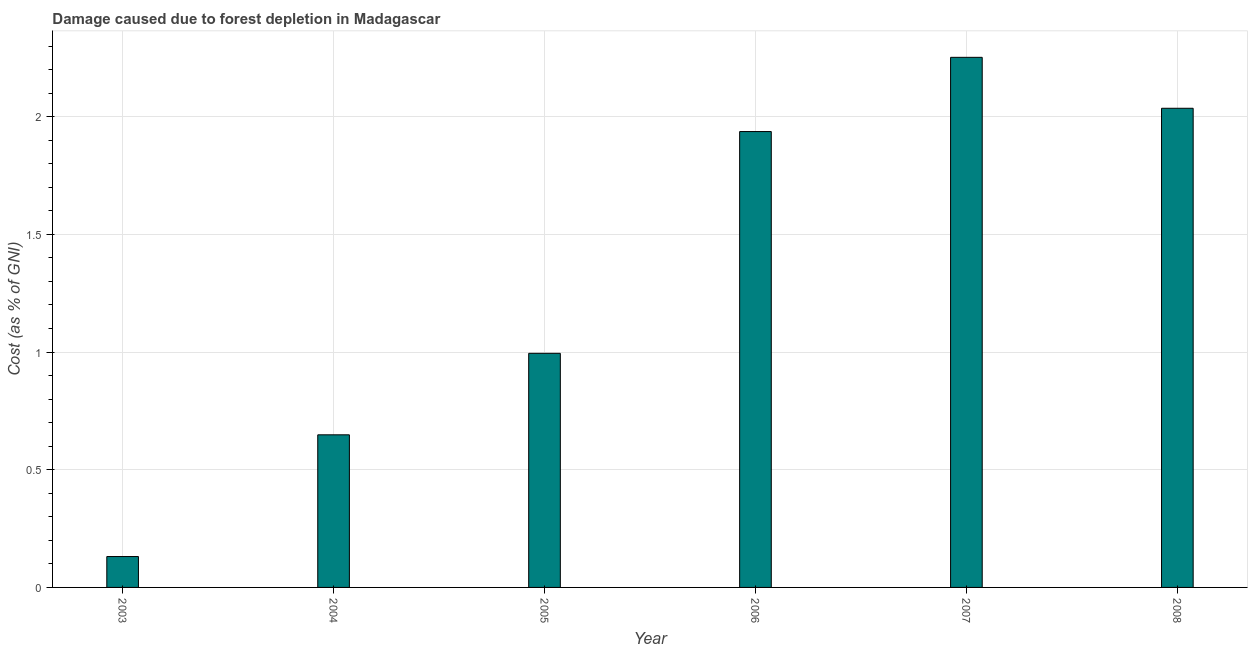Does the graph contain any zero values?
Ensure brevity in your answer.  No. Does the graph contain grids?
Your response must be concise. Yes. What is the title of the graph?
Give a very brief answer. Damage caused due to forest depletion in Madagascar. What is the label or title of the X-axis?
Provide a short and direct response. Year. What is the label or title of the Y-axis?
Offer a terse response. Cost (as % of GNI). What is the damage caused due to forest depletion in 2006?
Offer a terse response. 1.94. Across all years, what is the maximum damage caused due to forest depletion?
Your answer should be compact. 2.25. Across all years, what is the minimum damage caused due to forest depletion?
Your answer should be compact. 0.13. What is the sum of the damage caused due to forest depletion?
Provide a short and direct response. 8. What is the difference between the damage caused due to forest depletion in 2005 and 2007?
Provide a short and direct response. -1.26. What is the average damage caused due to forest depletion per year?
Make the answer very short. 1.33. What is the median damage caused due to forest depletion?
Provide a succinct answer. 1.47. In how many years, is the damage caused due to forest depletion greater than 1.3 %?
Provide a short and direct response. 3. What is the ratio of the damage caused due to forest depletion in 2004 to that in 2007?
Your response must be concise. 0.29. Is the damage caused due to forest depletion in 2003 less than that in 2008?
Your answer should be very brief. Yes. Is the difference between the damage caused due to forest depletion in 2004 and 2005 greater than the difference between any two years?
Your answer should be compact. No. What is the difference between the highest and the second highest damage caused due to forest depletion?
Provide a succinct answer. 0.22. What is the difference between the highest and the lowest damage caused due to forest depletion?
Your answer should be very brief. 2.12. How many bars are there?
Keep it short and to the point. 6. Are the values on the major ticks of Y-axis written in scientific E-notation?
Provide a succinct answer. No. What is the Cost (as % of GNI) of 2003?
Keep it short and to the point. 0.13. What is the Cost (as % of GNI) in 2004?
Ensure brevity in your answer.  0.65. What is the Cost (as % of GNI) of 2005?
Offer a terse response. 0.99. What is the Cost (as % of GNI) of 2006?
Give a very brief answer. 1.94. What is the Cost (as % of GNI) in 2007?
Provide a short and direct response. 2.25. What is the Cost (as % of GNI) in 2008?
Give a very brief answer. 2.04. What is the difference between the Cost (as % of GNI) in 2003 and 2004?
Keep it short and to the point. -0.52. What is the difference between the Cost (as % of GNI) in 2003 and 2005?
Give a very brief answer. -0.86. What is the difference between the Cost (as % of GNI) in 2003 and 2006?
Your answer should be very brief. -1.81. What is the difference between the Cost (as % of GNI) in 2003 and 2007?
Your answer should be very brief. -2.12. What is the difference between the Cost (as % of GNI) in 2003 and 2008?
Keep it short and to the point. -1.9. What is the difference between the Cost (as % of GNI) in 2004 and 2005?
Offer a terse response. -0.35. What is the difference between the Cost (as % of GNI) in 2004 and 2006?
Provide a succinct answer. -1.29. What is the difference between the Cost (as % of GNI) in 2004 and 2007?
Your answer should be compact. -1.6. What is the difference between the Cost (as % of GNI) in 2004 and 2008?
Provide a succinct answer. -1.39. What is the difference between the Cost (as % of GNI) in 2005 and 2006?
Offer a terse response. -0.94. What is the difference between the Cost (as % of GNI) in 2005 and 2007?
Ensure brevity in your answer.  -1.26. What is the difference between the Cost (as % of GNI) in 2005 and 2008?
Make the answer very short. -1.04. What is the difference between the Cost (as % of GNI) in 2006 and 2007?
Provide a short and direct response. -0.32. What is the difference between the Cost (as % of GNI) in 2006 and 2008?
Keep it short and to the point. -0.1. What is the difference between the Cost (as % of GNI) in 2007 and 2008?
Your response must be concise. 0.22. What is the ratio of the Cost (as % of GNI) in 2003 to that in 2004?
Your response must be concise. 0.2. What is the ratio of the Cost (as % of GNI) in 2003 to that in 2005?
Make the answer very short. 0.13. What is the ratio of the Cost (as % of GNI) in 2003 to that in 2006?
Ensure brevity in your answer.  0.07. What is the ratio of the Cost (as % of GNI) in 2003 to that in 2007?
Make the answer very short. 0.06. What is the ratio of the Cost (as % of GNI) in 2003 to that in 2008?
Provide a succinct answer. 0.06. What is the ratio of the Cost (as % of GNI) in 2004 to that in 2005?
Your answer should be compact. 0.65. What is the ratio of the Cost (as % of GNI) in 2004 to that in 2006?
Offer a terse response. 0.34. What is the ratio of the Cost (as % of GNI) in 2004 to that in 2007?
Offer a very short reply. 0.29. What is the ratio of the Cost (as % of GNI) in 2004 to that in 2008?
Give a very brief answer. 0.32. What is the ratio of the Cost (as % of GNI) in 2005 to that in 2006?
Make the answer very short. 0.51. What is the ratio of the Cost (as % of GNI) in 2005 to that in 2007?
Your answer should be compact. 0.44. What is the ratio of the Cost (as % of GNI) in 2005 to that in 2008?
Make the answer very short. 0.49. What is the ratio of the Cost (as % of GNI) in 2006 to that in 2007?
Provide a succinct answer. 0.86. What is the ratio of the Cost (as % of GNI) in 2006 to that in 2008?
Provide a succinct answer. 0.95. What is the ratio of the Cost (as % of GNI) in 2007 to that in 2008?
Give a very brief answer. 1.11. 